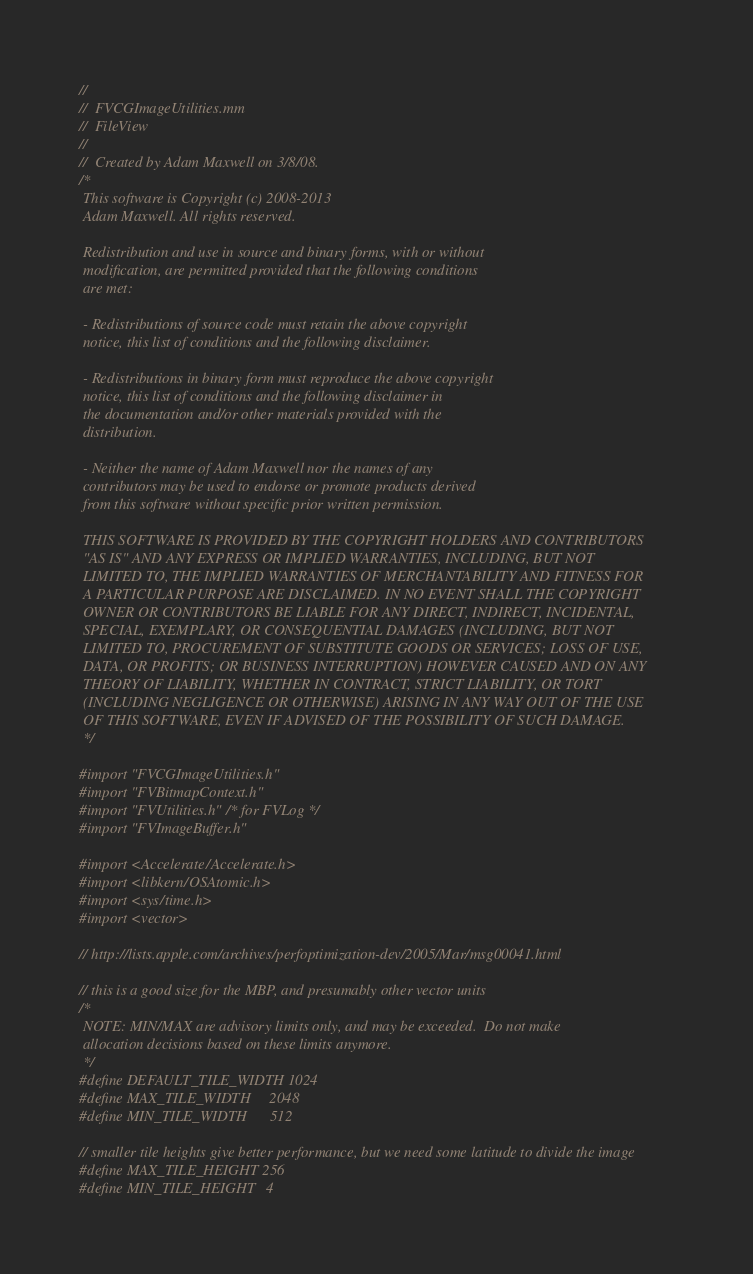<code> <loc_0><loc_0><loc_500><loc_500><_ObjectiveC_>//
//  FVCGImageUtilities.mm
//  FileView
//
//  Created by Adam Maxwell on 3/8/08.
/*
 This software is Copyright (c) 2008-2013
 Adam Maxwell. All rights reserved.
 
 Redistribution and use in source and binary forms, with or without
 modification, are permitted provided that the following conditions
 are met:
 
 - Redistributions of source code must retain the above copyright
 notice, this list of conditions and the following disclaimer.
 
 - Redistributions in binary form must reproduce the above copyright
 notice, this list of conditions and the following disclaimer in
 the documentation and/or other materials provided with the
 distribution.
 
 - Neither the name of Adam Maxwell nor the names of any
 contributors may be used to endorse or promote products derived
 from this software without specific prior written permission.
 
 THIS SOFTWARE IS PROVIDED BY THE COPYRIGHT HOLDERS AND CONTRIBUTORS
 "AS IS" AND ANY EXPRESS OR IMPLIED WARRANTIES, INCLUDING, BUT NOT
 LIMITED TO, THE IMPLIED WARRANTIES OF MERCHANTABILITY AND FITNESS FOR
 A PARTICULAR PURPOSE ARE DISCLAIMED. IN NO EVENT SHALL THE COPYRIGHT
 OWNER OR CONTRIBUTORS BE LIABLE FOR ANY DIRECT, INDIRECT, INCIDENTAL,
 SPECIAL, EXEMPLARY, OR CONSEQUENTIAL DAMAGES (INCLUDING, BUT NOT
 LIMITED TO, PROCUREMENT OF SUBSTITUTE GOODS OR SERVICES; LOSS OF USE,
 DATA, OR PROFITS; OR BUSINESS INTERRUPTION) HOWEVER CAUSED AND ON ANY
 THEORY OF LIABILITY, WHETHER IN CONTRACT, STRICT LIABILITY, OR TORT
 (INCLUDING NEGLIGENCE OR OTHERWISE) ARISING IN ANY WAY OUT OF THE USE
 OF THIS SOFTWARE, EVEN IF ADVISED OF THE POSSIBILITY OF SUCH DAMAGE.
 */

#import "FVCGImageUtilities.h"
#import "FVBitmapContext.h"
#import "FVUtilities.h" /* for FVLog */
#import "FVImageBuffer.h"

#import <Accelerate/Accelerate.h>
#import <libkern/OSAtomic.h>
#import <sys/time.h>
#import <vector>

// http://lists.apple.com/archives/perfoptimization-dev/2005/Mar/msg00041.html

// this is a good size for the MBP, and presumably other vector units
/*
 NOTE: MIN/MAX are advisory limits only, and may be exceeded.  Do not make
 allocation decisions based on these limits anymore.
 */
#define DEFAULT_TILE_WIDTH 1024
#define MAX_TILE_WIDTH     2048
#define MIN_TILE_WIDTH      512

// smaller tile heights give better performance, but we need some latitude to divide the image
#define MAX_TILE_HEIGHT 256
#define MIN_TILE_HEIGHT   4</code> 